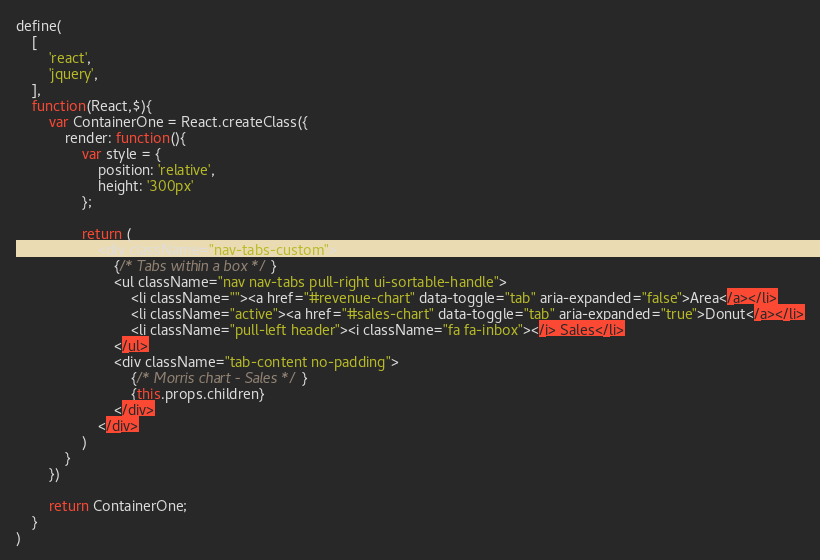Convert code to text. <code><loc_0><loc_0><loc_500><loc_500><_JavaScript_>define(
    [
        'react',
        'jquery',
    ],
    function(React,$){
    	var ContainerOne = React.createClass({
    		render: function(){
                var style = {
                    position: 'relative',
                    height: '300px'
                };

    			return (
    				<div className="nav-tabs-custom">
                        {/* Tabs within a box */}
                        <ul className="nav nav-tabs pull-right ui-sortable-handle">
                            <li className=""><a href="#revenue-chart" data-toggle="tab" aria-expanded="false">Area</a></li>
                            <li className="active"><a href="#sales-chart" data-toggle="tab" aria-expanded="true">Donut</a></li>
                            <li className="pull-left header"><i className="fa fa-inbox"></i> Sales</li>
                        </ul>
                        <div className="tab-content no-padding">
                            {/* Morris chart - Sales */}
                            {this.props.children}
                        </div>
                    </div>
    			)
    		}
    	})

    	return ContainerOne;
    }   
)     </code> 